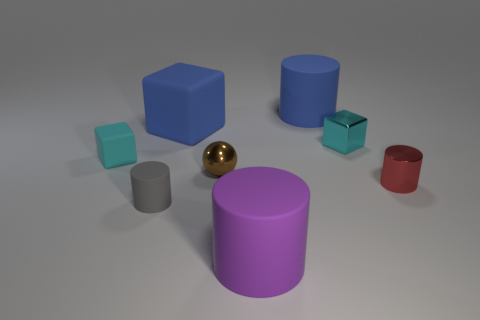Add 1 large yellow metal cubes. How many objects exist? 9 Subtract all balls. How many objects are left? 7 Subtract 1 red cylinders. How many objects are left? 7 Subtract all large purple rubber spheres. Subtract all small blocks. How many objects are left? 6 Add 5 large purple rubber objects. How many large purple rubber objects are left? 6 Add 2 big gray balls. How many big gray balls exist? 2 